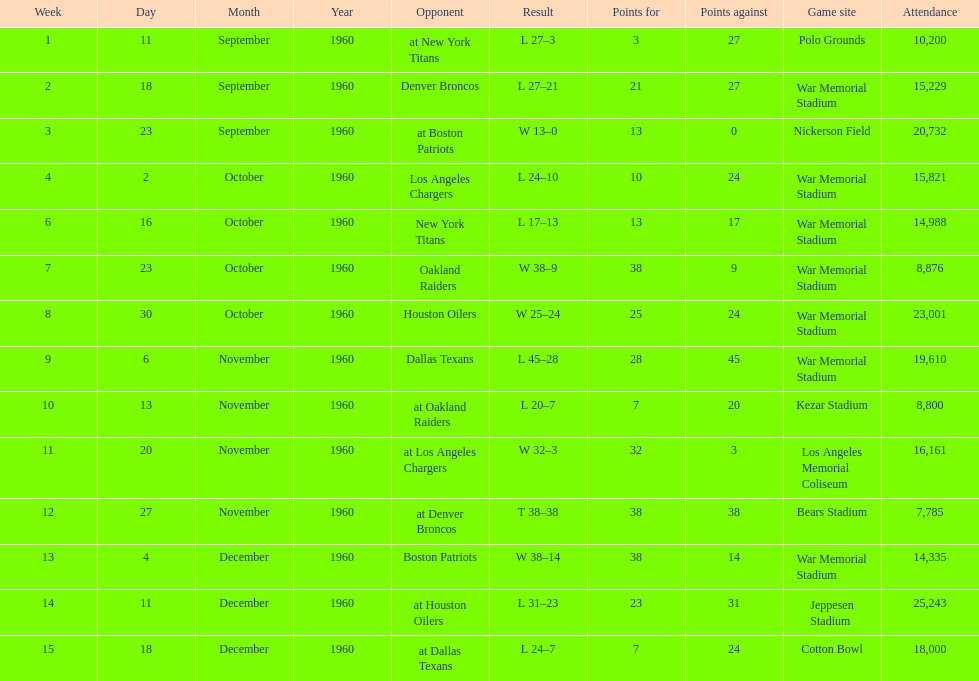What was the largest difference of points in a single game? 29. 